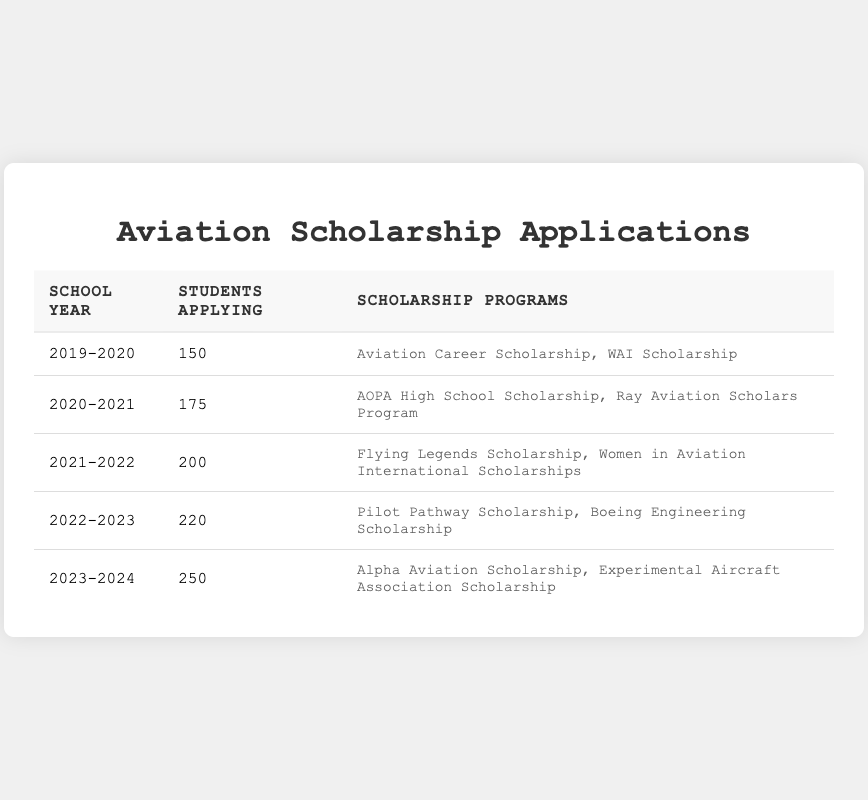What is the total number of students applying for aviation scholarships from 2019 to 2024? To find the total number of students, add the number of students applying each school year: 150 + 175 + 200 + 220 + 250 = 1095.
Answer: 1095 Which school year had the highest number of applications? By looking at the table, the school year 2023-2024 shows the highest number of students applying, with 250 applicants.
Answer: 2023-2024 How many students applied for aviation scholarships in the school year 2021-2022? The table directly shows that 200 students applied in the school year 2021-2022.
Answer: 200 Did more students apply for scholarships in 2022-2023 than in 2021-2022? Comparing the numbers, 220 students applied in 2022-2023, which is greater than the 200 students who applied in 2021-2022.
Answer: Yes What is the average number of students applying for scholarships from 2019 to 2024? To calculate the average, sum the number of students (1095) and divide by the number of school years (5): 1095 / 5 = 219.
Answer: 219 By how much did the number of students applying increase from 2020-2021 to 2021-2022? The number of students for 2020-2021 was 175, and for 2021-2022 it was 200. The increase is calculated as 200 - 175 = 25.
Answer: 25 How many scholarship programs were available for students in the 2023-2024 school year? The table lists two scholarship programs available for the 2023-2024 school year.
Answer: 2 Which school year saw an increase of over 20% in applications compared to the previous year? From 2021-2022 to 2022-2023, students increased from 200 to 220. The percentage increase is (220 - 200) / 200 * 100 = 10%. From 2022-2023 to 2023-2024, students increased from 220 to 250, giving (250 - 220) / 220 * 100 = about 13.64%. Thus, no year experienced over 20% increase from its preceding year based on the given data.
Answer: No What are the scholarship programs listed for the school year 2022-2023? The table indicates that the scholarship programs available for the school year 2022-2023 were the Pilot Pathway Scholarship and the Boeing Engineering Scholarship.
Answer: Pilot Pathway Scholarship, Boeing Engineering Scholarship For which school year was the increase in student applications the largest? The largest increase is from 2022-2023 (220) to 2023-2024 (250), which is 30 students (250 - 220).
Answer: 2022-2023 to 2023-2024 